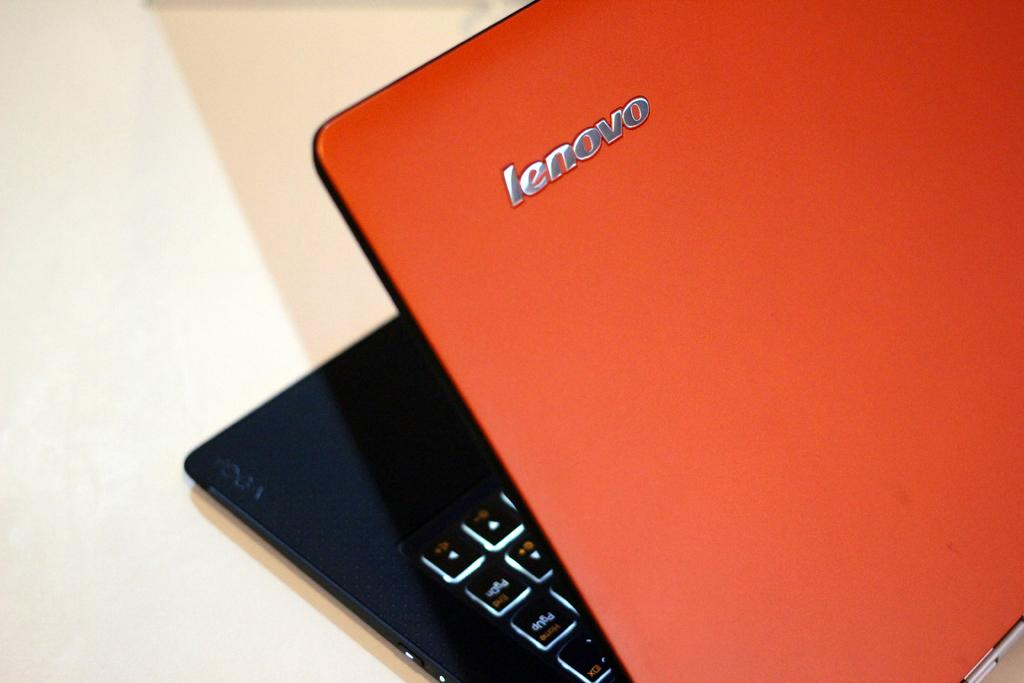<image>
Relay a brief, clear account of the picture shown. An orange and black Lenovo laptop is open at roughly a 35 degree angle. 